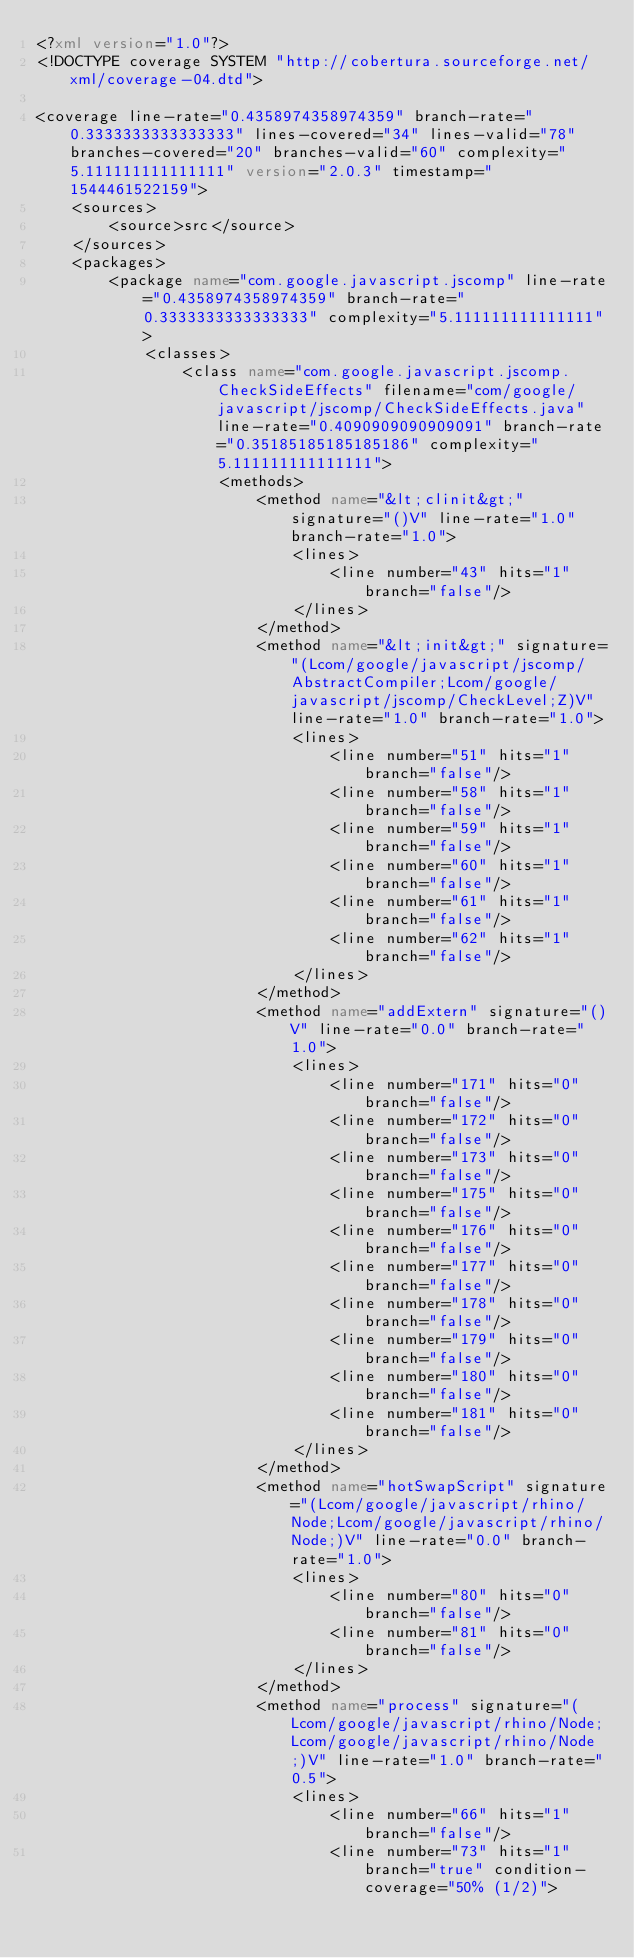Convert code to text. <code><loc_0><loc_0><loc_500><loc_500><_XML_><?xml version="1.0"?>
<!DOCTYPE coverage SYSTEM "http://cobertura.sourceforge.net/xml/coverage-04.dtd">

<coverage line-rate="0.4358974358974359" branch-rate="0.3333333333333333" lines-covered="34" lines-valid="78" branches-covered="20" branches-valid="60" complexity="5.111111111111111" version="2.0.3" timestamp="1544461522159">
	<sources>
		<source>src</source>
	</sources>
	<packages>
		<package name="com.google.javascript.jscomp" line-rate="0.4358974358974359" branch-rate="0.3333333333333333" complexity="5.111111111111111">
			<classes>
				<class name="com.google.javascript.jscomp.CheckSideEffects" filename="com/google/javascript/jscomp/CheckSideEffects.java" line-rate="0.4090909090909091" branch-rate="0.35185185185185186" complexity="5.111111111111111">
					<methods>
						<method name="&lt;clinit&gt;" signature="()V" line-rate="1.0" branch-rate="1.0">
							<lines>
								<line number="43" hits="1" branch="false"/>
							</lines>
						</method>
						<method name="&lt;init&gt;" signature="(Lcom/google/javascript/jscomp/AbstractCompiler;Lcom/google/javascript/jscomp/CheckLevel;Z)V" line-rate="1.0" branch-rate="1.0">
							<lines>
								<line number="51" hits="1" branch="false"/>
								<line number="58" hits="1" branch="false"/>
								<line number="59" hits="1" branch="false"/>
								<line number="60" hits="1" branch="false"/>
								<line number="61" hits="1" branch="false"/>
								<line number="62" hits="1" branch="false"/>
							</lines>
						</method>
						<method name="addExtern" signature="()V" line-rate="0.0" branch-rate="1.0">
							<lines>
								<line number="171" hits="0" branch="false"/>
								<line number="172" hits="0" branch="false"/>
								<line number="173" hits="0" branch="false"/>
								<line number="175" hits="0" branch="false"/>
								<line number="176" hits="0" branch="false"/>
								<line number="177" hits="0" branch="false"/>
								<line number="178" hits="0" branch="false"/>
								<line number="179" hits="0" branch="false"/>
								<line number="180" hits="0" branch="false"/>
								<line number="181" hits="0" branch="false"/>
							</lines>
						</method>
						<method name="hotSwapScript" signature="(Lcom/google/javascript/rhino/Node;Lcom/google/javascript/rhino/Node;)V" line-rate="0.0" branch-rate="1.0">
							<lines>
								<line number="80" hits="0" branch="false"/>
								<line number="81" hits="0" branch="false"/>
							</lines>
						</method>
						<method name="process" signature="(Lcom/google/javascript/rhino/Node;Lcom/google/javascript/rhino/Node;)V" line-rate="1.0" branch-rate="0.5">
							<lines>
								<line number="66" hits="1" branch="false"/>
								<line number="73" hits="1" branch="true" condition-coverage="50% (1/2)"></code> 